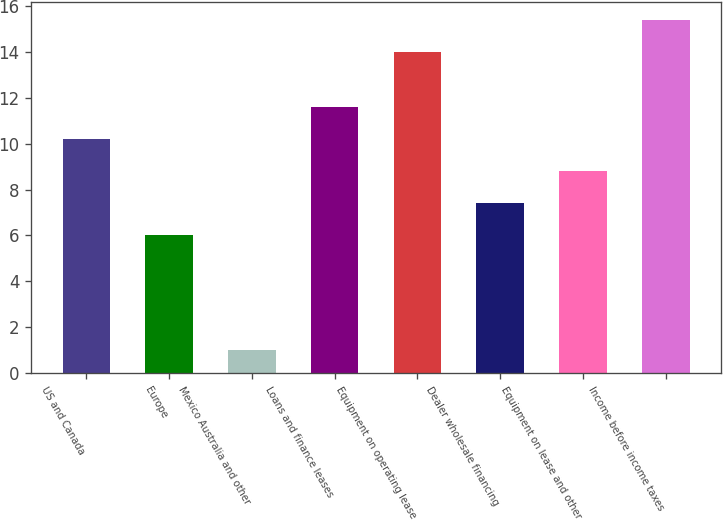Convert chart. <chart><loc_0><loc_0><loc_500><loc_500><bar_chart><fcel>US and Canada<fcel>Europe<fcel>Mexico Australia and other<fcel>Loans and finance leases<fcel>Equipment on operating lease<fcel>Dealer wholesale financing<fcel>Equipment on lease and other<fcel>Income before income taxes<nl><fcel>10.2<fcel>6<fcel>1<fcel>11.6<fcel>14<fcel>7.4<fcel>8.8<fcel>15.4<nl></chart> 